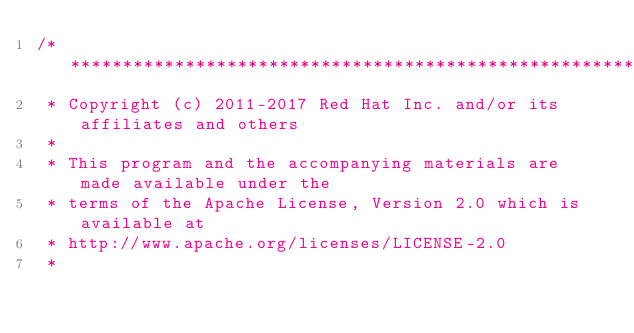<code> <loc_0><loc_0><loc_500><loc_500><_Ceylon_>/********************************************************************************
 * Copyright (c) 2011-2017 Red Hat Inc. and/or its affiliates and others
 *
 * This program and the accompanying materials are made available under the 
 * terms of the Apache License, Version 2.0 which is available at
 * http://www.apache.org/licenses/LICENSE-2.0
 *</code> 